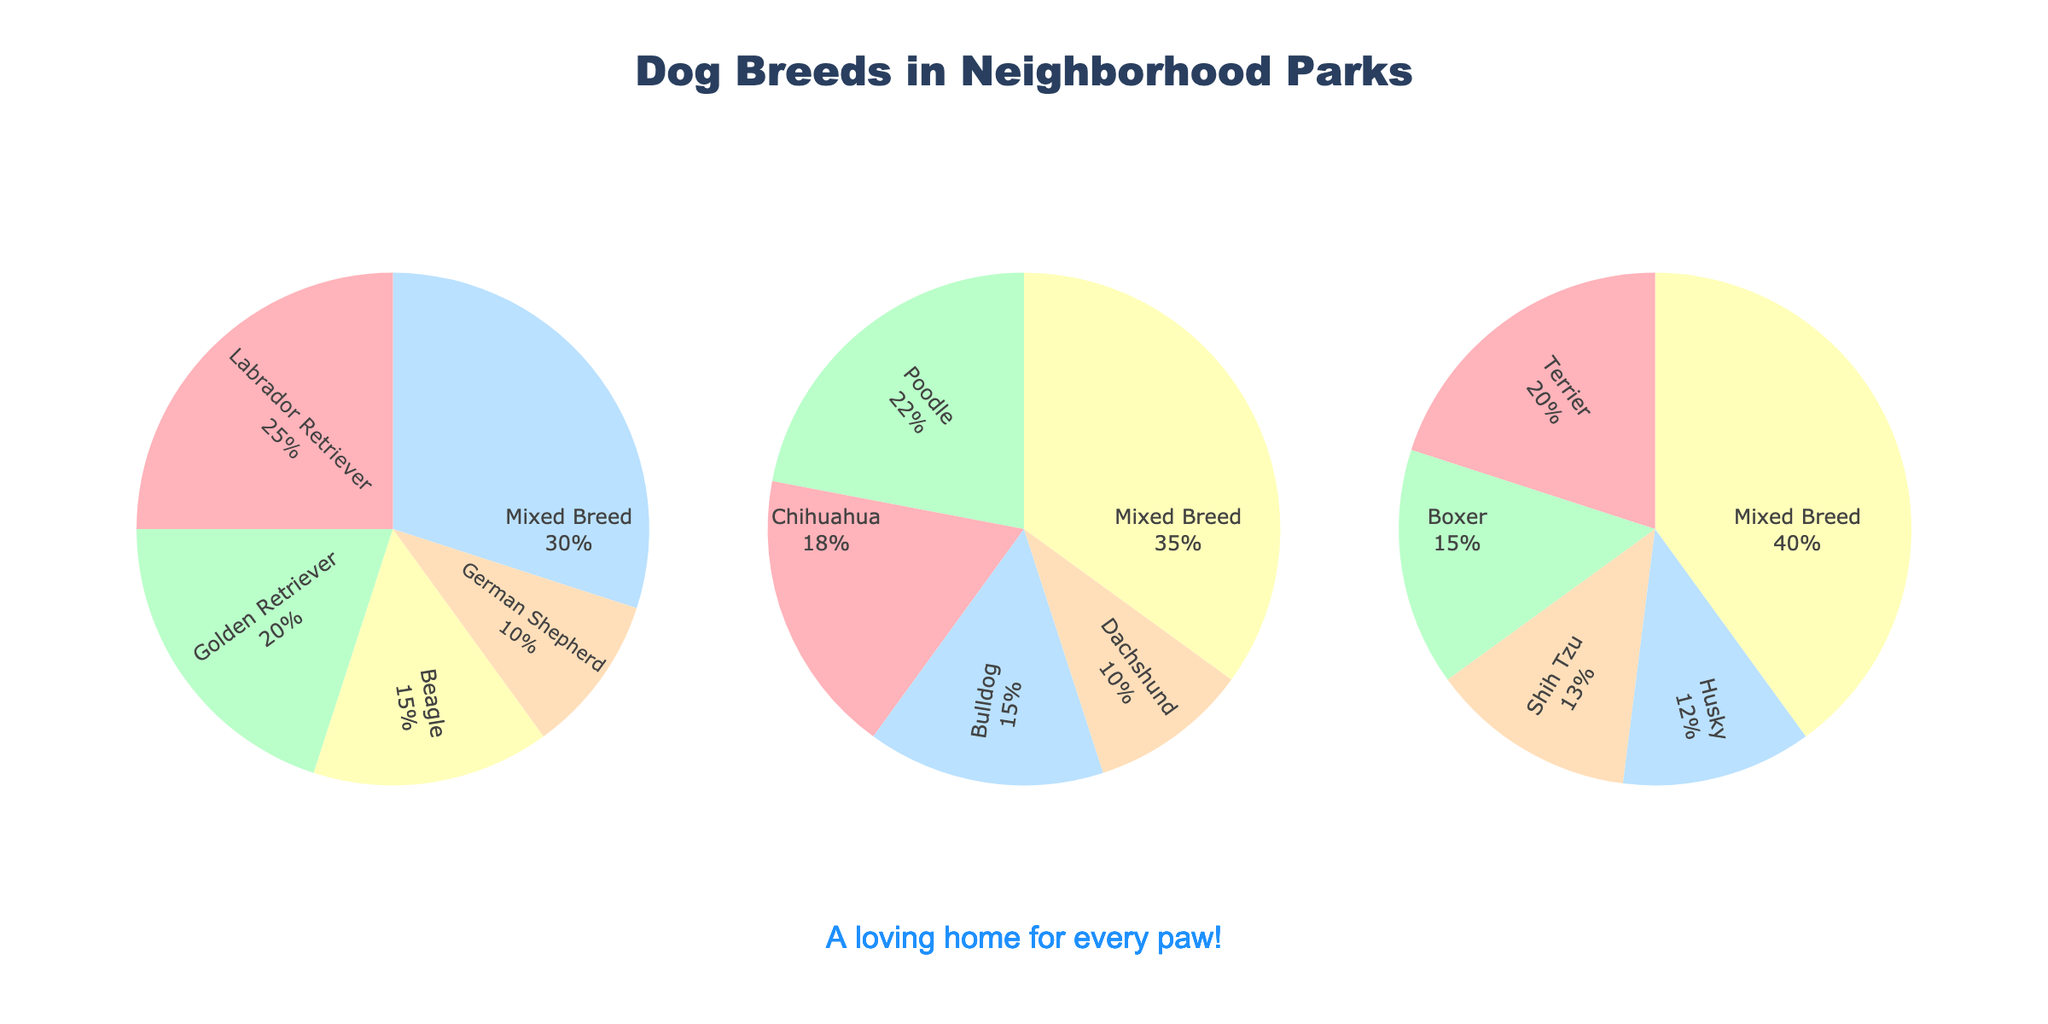What is the title of the figure? The title of the figure is displayed at the top, and it reads "Dog Breeds in Neighborhood Parks".
Answer: Dog Breeds in Neighborhood Parks What percentage of dogs in Central Park are Golden Retrievers? In the pie chart for Central Park, the Golden Retrievers slice shows 20%.
Answer: 20% Which breed has the highest percentage in Riverside Dog Park? In Riverside Dog Park's pie chart, the breed with the largest slice is Mixed Breed, which shows 35%.
Answer: Mixed Breed What is the combined percentage of German Shepherds and Beagles in Central Park? Adding the percentages for German Shepherds (10%) and Beagles (15%) gives 10% + 15% = 25%.
Answer: 25% Compare the percentage of Mixed Breed dogs in all three parks. Which park has the highest percentage? Mixed Breed dogs have percentages of 30% in Central Park, 35% in Riverside Dog Park, and 40% in Neighborhood Green. The highest percentage is in Neighborhood Green.
Answer: Neighborhood Green What is the least common breed in Riverside Dog Park and its percentage? The breed with the smallest slice in Riverside Dog Park is Dachshund, which shows 10%.
Answer: Dachshund, 10% Which park has a higher total percentage of small dog breeds such as Chihuahua and Dachshund? In Riverside Dog Park, the percentages for Chihuahua and Dachshund are 18% and 10% respectively, totaling 28%. In Central Park, there are no Chihuahuas and Dachshunds. Thus, Riverside Dog Park has 28%.
Answer: Riverside Dog Park How do the percentages for Terrier, Boxer, and Shih Tzu in Neighborhood Green compare to each other? In Neighborhood Green, Terrier has 20%, Boxer has 15%, and Shih Tzu has 13%. Terrier > Boxer > Shih Tzu in decreasing order.
Answer: Terrier > Boxer > Shih Tzu By how many percentage points does the percentage of Mixed Breed dogs in Neighborhood Green surpass that in Central Park? The percentage of Mixed Breed dogs in Neighborhood Green is 40% and in Central Park it is 30%. The difference is 40% - 30% = 10%.
Answer: 10% If you were to adopt a Labrador Retriever, which park would you most likely find it based on the provided data? The percentage of Labrador Retrievers in Central Park is 25%. Labrador Retrievers are not mentioned in Riverside Dog Park and Neighborhood Green. Therefore, Central Park is the most likely place to find one.
Answer: Central Park 